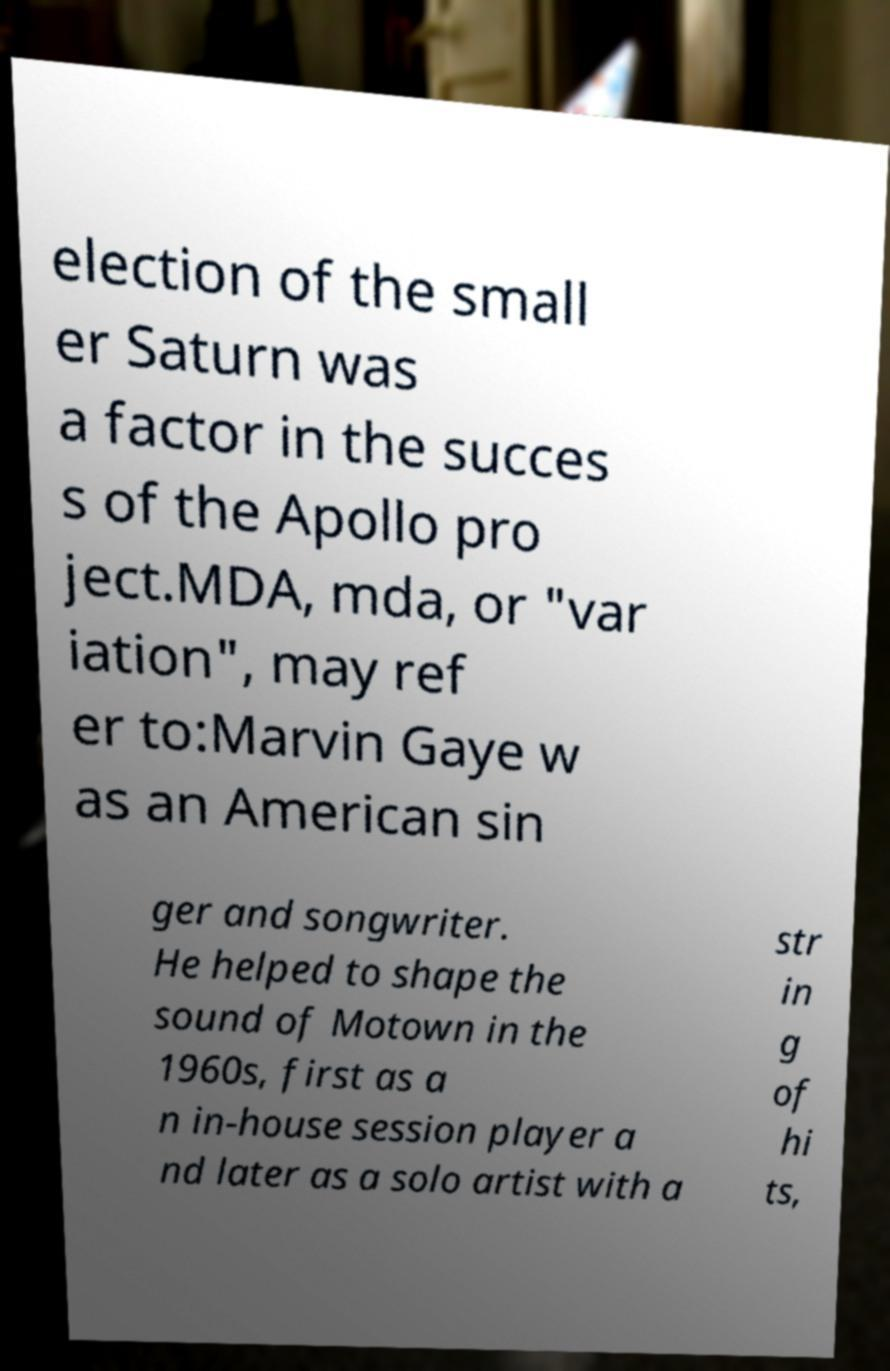There's text embedded in this image that I need extracted. Can you transcribe it verbatim? election of the small er Saturn was a factor in the succes s of the Apollo pro ject.MDA, mda, or "var iation", may ref er to:Marvin Gaye w as an American sin ger and songwriter. He helped to shape the sound of Motown in the 1960s, first as a n in-house session player a nd later as a solo artist with a str in g of hi ts, 